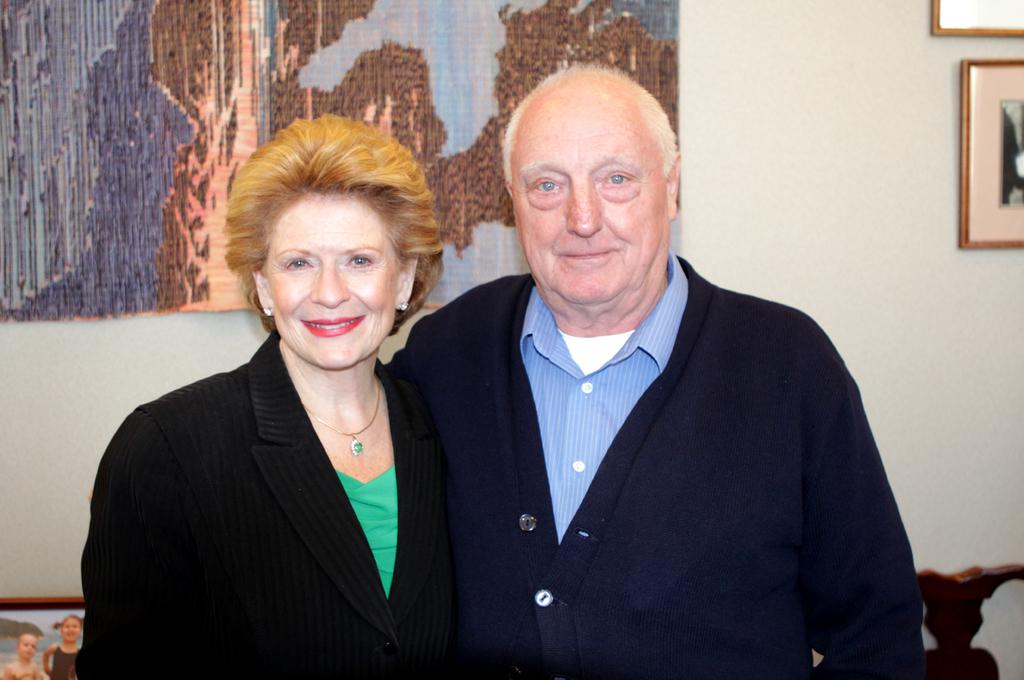Who is present in the image? There is a man and a woman in the image. What expressions do the man and woman have in the image? Both the man and the woman are smiling in the image. What can be seen in the background of the image? There are objects and frames on the wall in the background of the image. What type of vest is the man wearing in the image? There is no vest visible in the image; the man is not wearing one. Can you see a match being lit in the image? There is no match or any indication of fire in the image. 